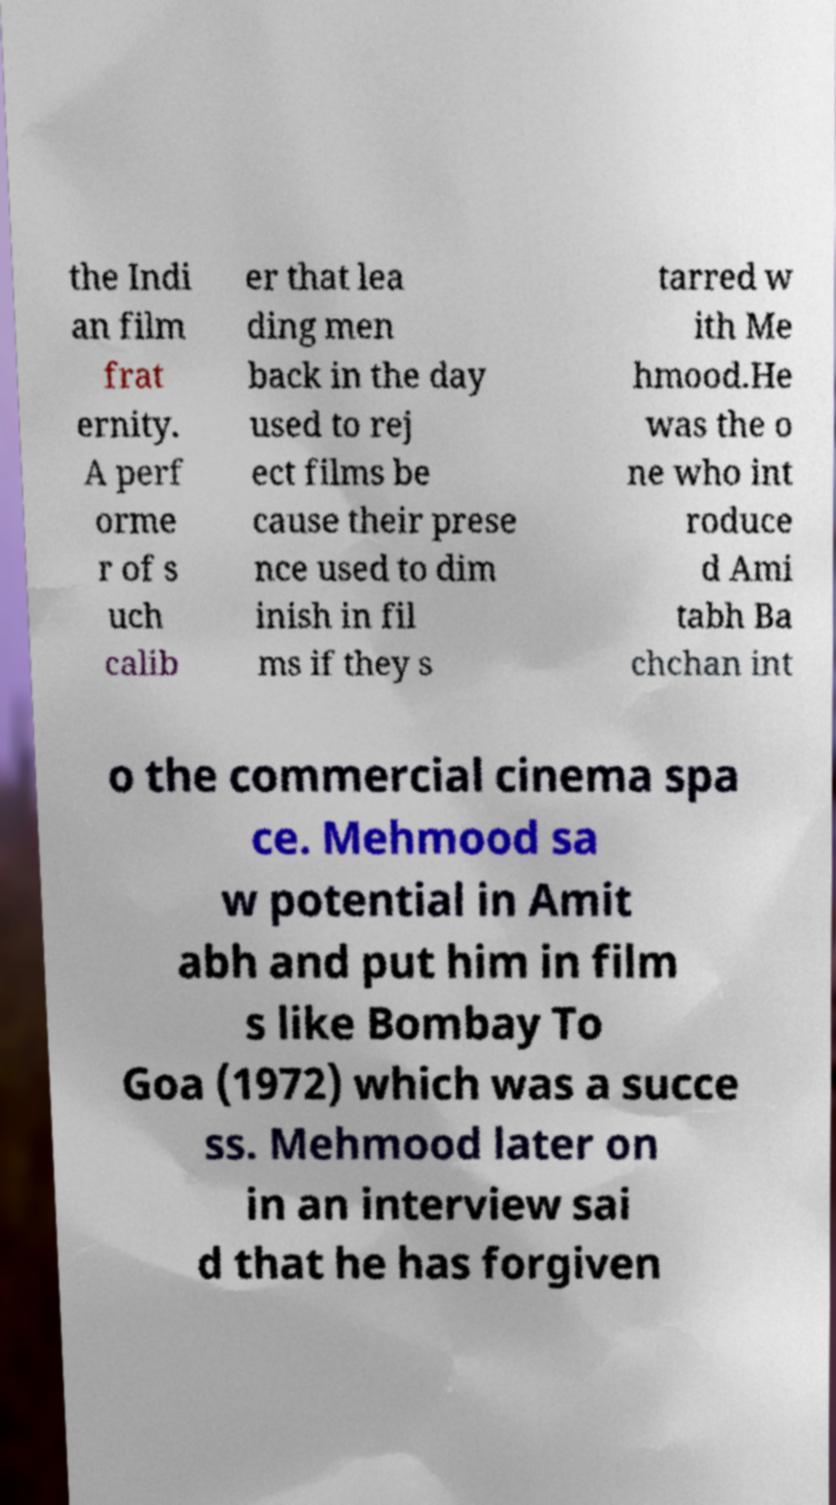Please identify and transcribe the text found in this image. the Indi an film frat ernity. A perf orme r of s uch calib er that lea ding men back in the day used to rej ect films be cause their prese nce used to dim inish in fil ms if they s tarred w ith Me hmood.He was the o ne who int roduce d Ami tabh Ba chchan int o the commercial cinema spa ce. Mehmood sa w potential in Amit abh and put him in film s like Bombay To Goa (1972) which was a succe ss. Mehmood later on in an interview sai d that he has forgiven 